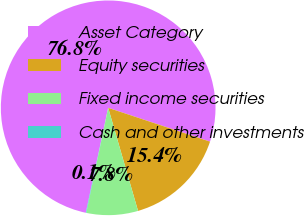Convert chart. <chart><loc_0><loc_0><loc_500><loc_500><pie_chart><fcel>Asset Category<fcel>Equity securities<fcel>Fixed income securities<fcel>Cash and other investments<nl><fcel>76.76%<fcel>15.41%<fcel>7.75%<fcel>0.08%<nl></chart> 